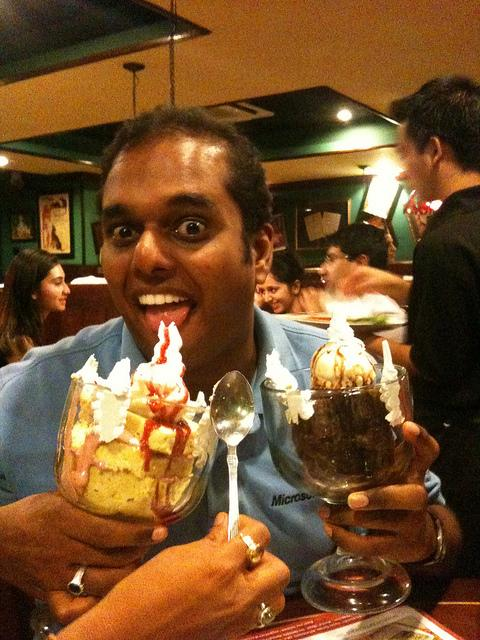What company might the man in the blue shirt work for?

Choices:
A) apple
B) microsoft
C) samsung
D) sony microsoft 